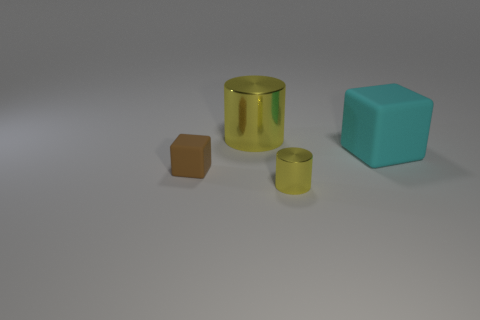Add 3 tiny brown rubber blocks. How many objects exist? 7 Subtract all small brown matte things. Subtract all tiny cylinders. How many objects are left? 2 Add 3 matte things. How many matte things are left? 5 Add 2 tiny yellow cylinders. How many tiny yellow cylinders exist? 3 Subtract 0 red spheres. How many objects are left? 4 